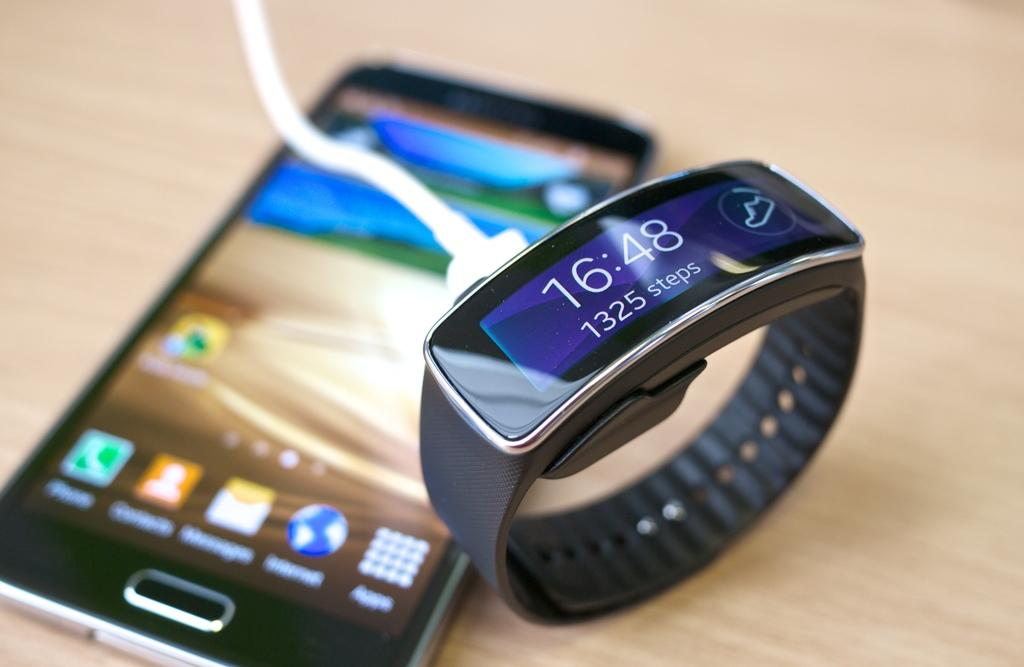What electronic device is visible in the image? There is a mobile in the image. What other electronic device can be seen in the image? There is a smart watch in the image. What is connecting the mobile and smart watch in the image? There is a cable in the image. On what surface are the mobile, smart watch, and cable placed? The mobile, smart watch, and cable are on a wooden platform. What is the name of the person who gave birth to the mobile in the image? The mobile is an inanimate object and does not have a birth or a person who gave birth to it. 